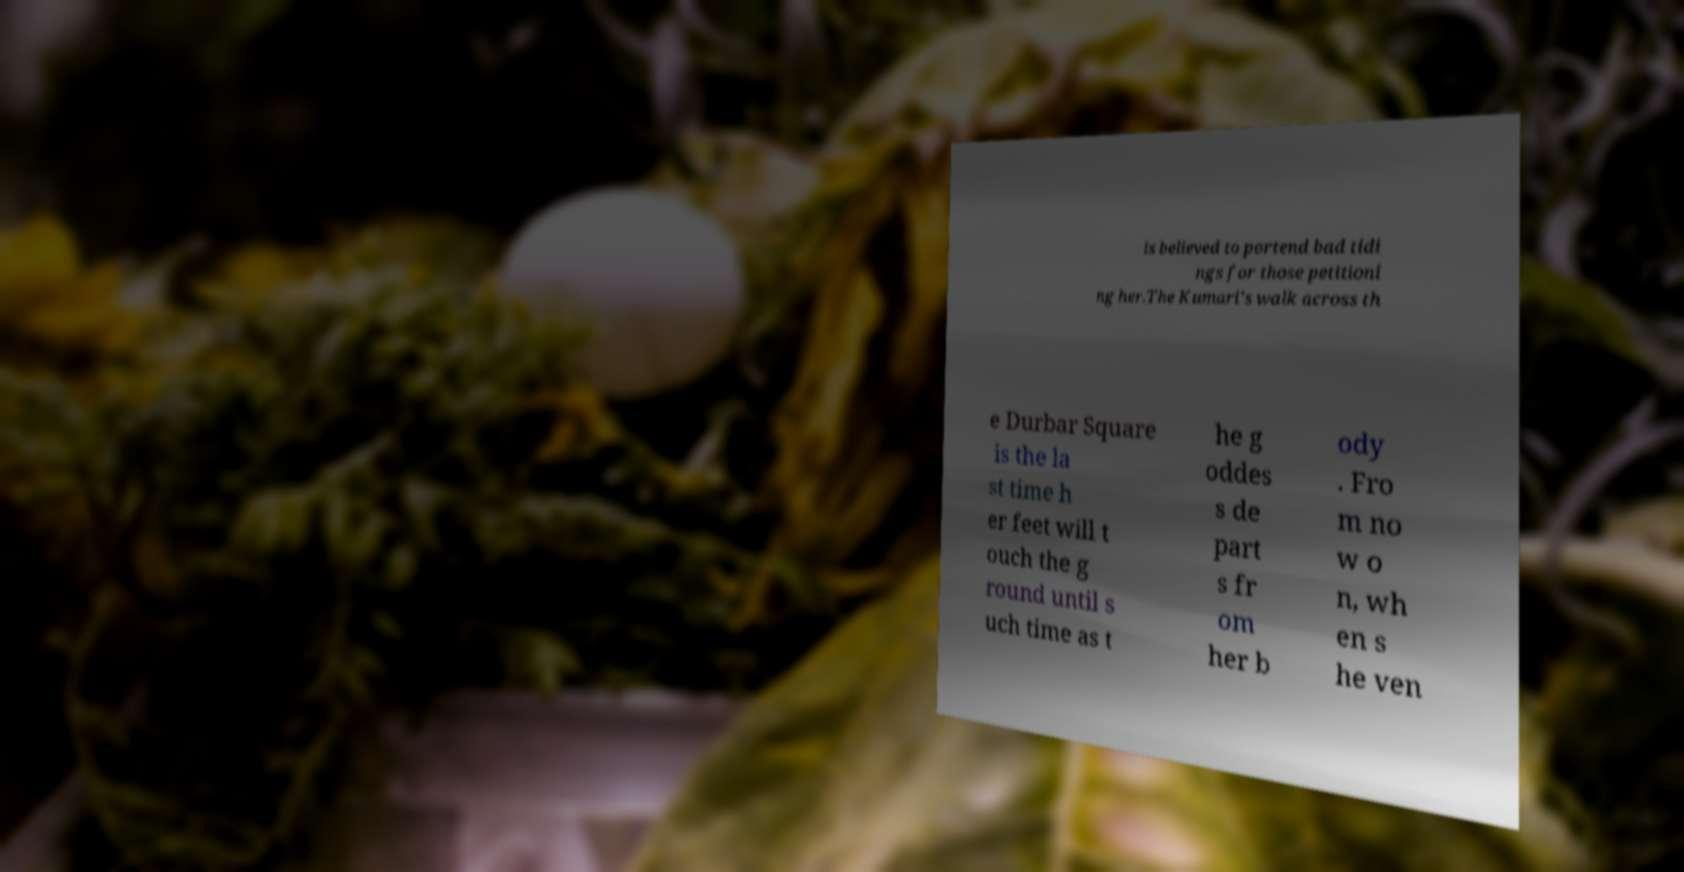Please identify and transcribe the text found in this image. is believed to portend bad tidi ngs for those petitioni ng her.The Kumari's walk across th e Durbar Square is the la st time h er feet will t ouch the g round until s uch time as t he g oddes s de part s fr om her b ody . Fro m no w o n, wh en s he ven 